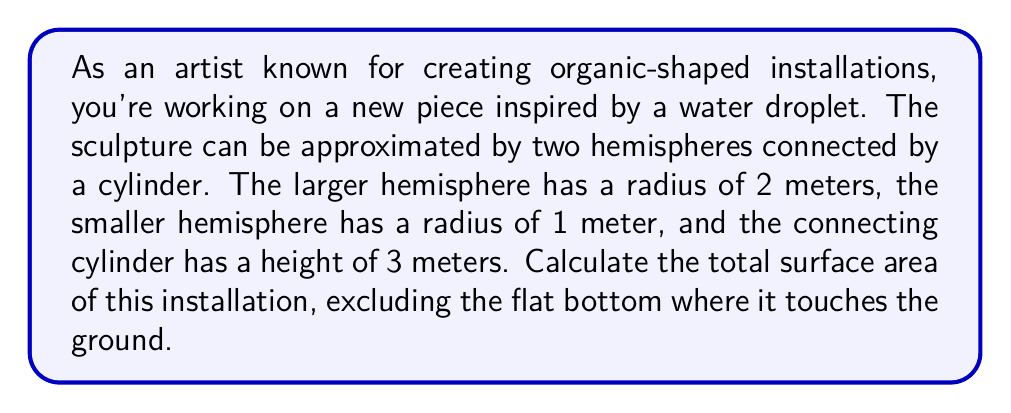Provide a solution to this math problem. Let's break this down step-by-step:

1) First, let's recall the formulas we'll need:
   - Surface area of a sphere: $A = 4\pi r^2$
   - Surface area of a hemisphere: $A = 2\pi r^2$
   - Lateral surface area of a cylinder: $A = 2\pi rh$

2) Calculate the surface area of the larger hemisphere:
   $A_1 = 2\pi r^2 = 2\pi (2^2) = 8\pi$ square meters

3) Calculate the surface area of the smaller hemisphere:
   $A_2 = 2\pi r^2 = 2\pi (1^2) = 2\pi$ square meters

4) Calculate the lateral surface area of the connecting cylinder:
   The radius of this cylinder is the same as the larger hemisphere.
   $A_3 = 2\pi rh = 2\pi (2)(3) = 12\pi$ square meters

5) Sum up all the areas:
   $A_{\text{total}} = A_1 + A_2 + A_3 = 8\pi + 2\pi + 12\pi = 22\pi$ square meters

[asy]
import geometry;

size(200);

// Draw larger hemisphere
draw(arc((0,0), 2, 180, 360));

// Draw smaller hemisphere
draw(arc((0,3), 1, 0, 180));

// Draw connecting cylinder
draw((-2,0)--(-2,3));
draw((2,0)--(2,3));

label("2m", (2.3,0), E);
label("1m", (1.3,3), E);
label("3m", (2.1,1.5), E);
[/asy]
Answer: The total surface area of the installation is $22\pi$ square meters, or approximately 69.12 square meters. 